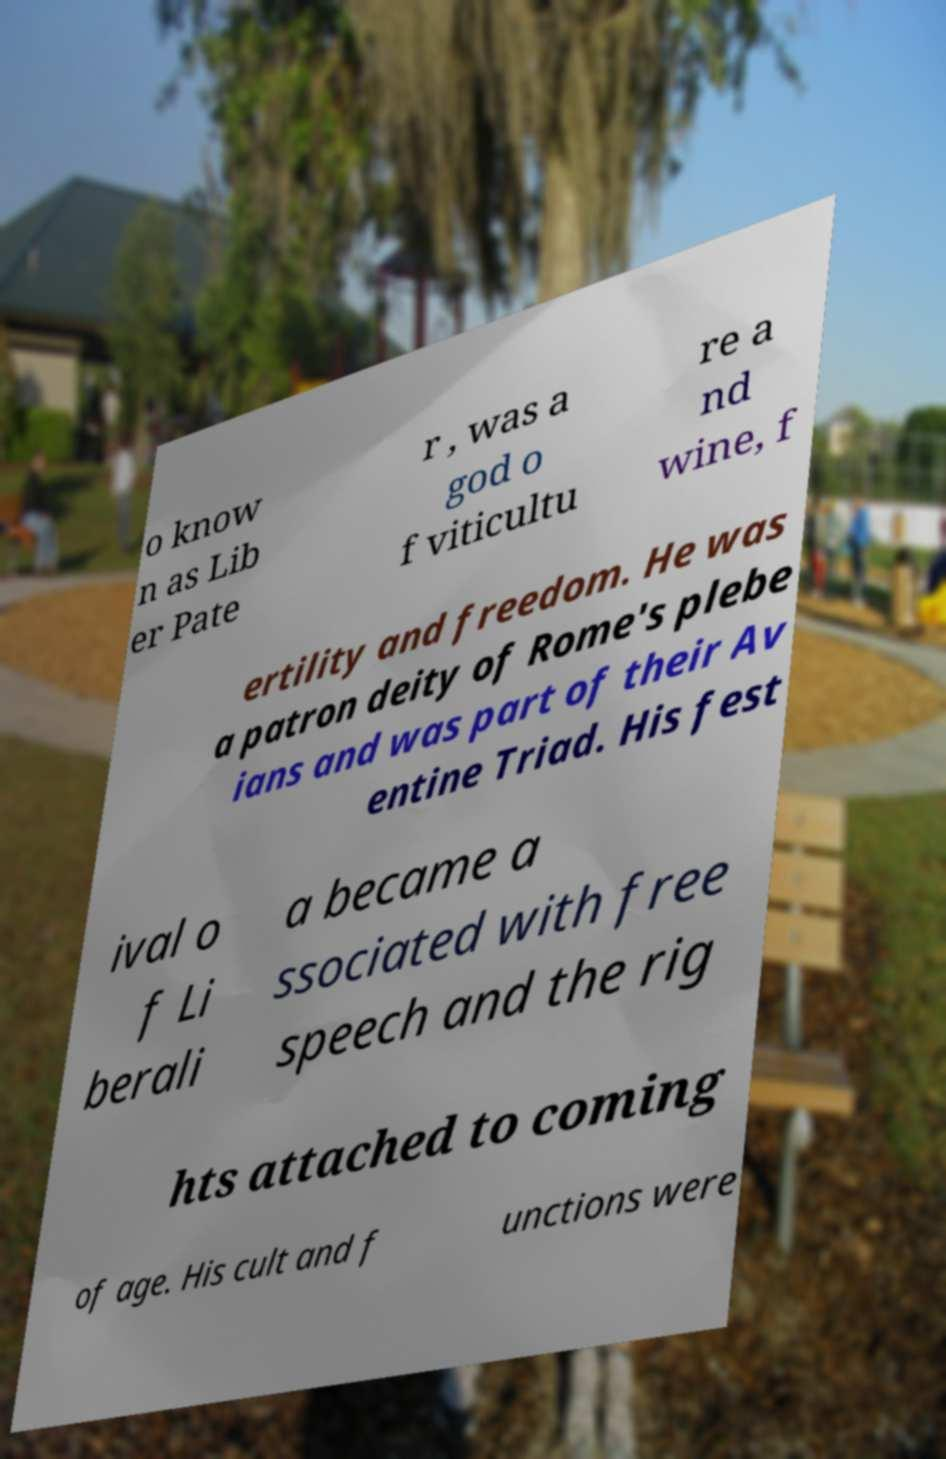There's text embedded in this image that I need extracted. Can you transcribe it verbatim? o know n as Lib er Pate r , was a god o f viticultu re a nd wine, f ertility and freedom. He was a patron deity of Rome's plebe ians and was part of their Av entine Triad. His fest ival o f Li berali a became a ssociated with free speech and the rig hts attached to coming of age. His cult and f unctions were 